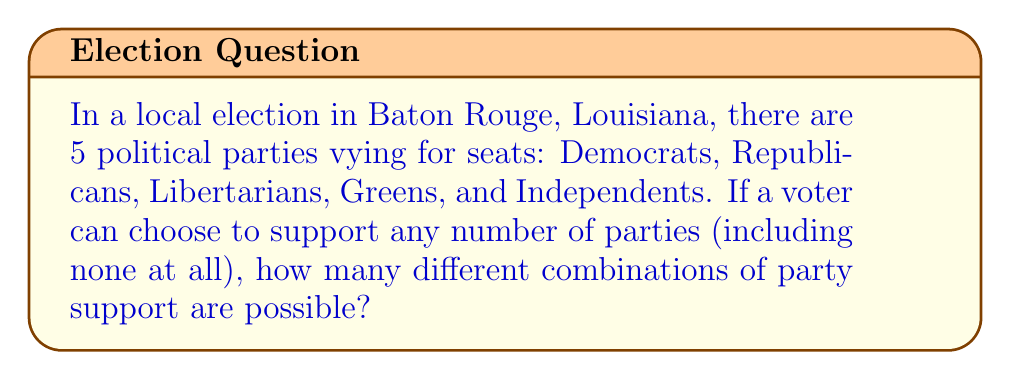Show me your answer to this math problem. Let's approach this step-by-step:

1) For each party, a voter has two choices: support or not support.

2) This scenario is equivalent to making 5 independent binary choices, one for each party.

3) In combinatorics, when we have independent choices, we multiply the number of options for each choice.

4) For each party, there are 2 choices (support or not support).

5) We have 5 parties in total.

6) Therefore, the total number of combinations is:

   $$ 2 \times 2 \times 2 \times 2 \times 2 = 2^5 $$

7) We can calculate this:

   $$ 2^5 = 32 $$

8) This includes all possibilities, from supporting no parties (which is one of the combinations) to supporting all 5 parties, and every combination in between.

This result reflects the diverse political landscape of Louisiana, where voters might support multiple parties based on local issues and candidates, contributing to the complex dynamics of community development through politics.
Answer: $32$ 